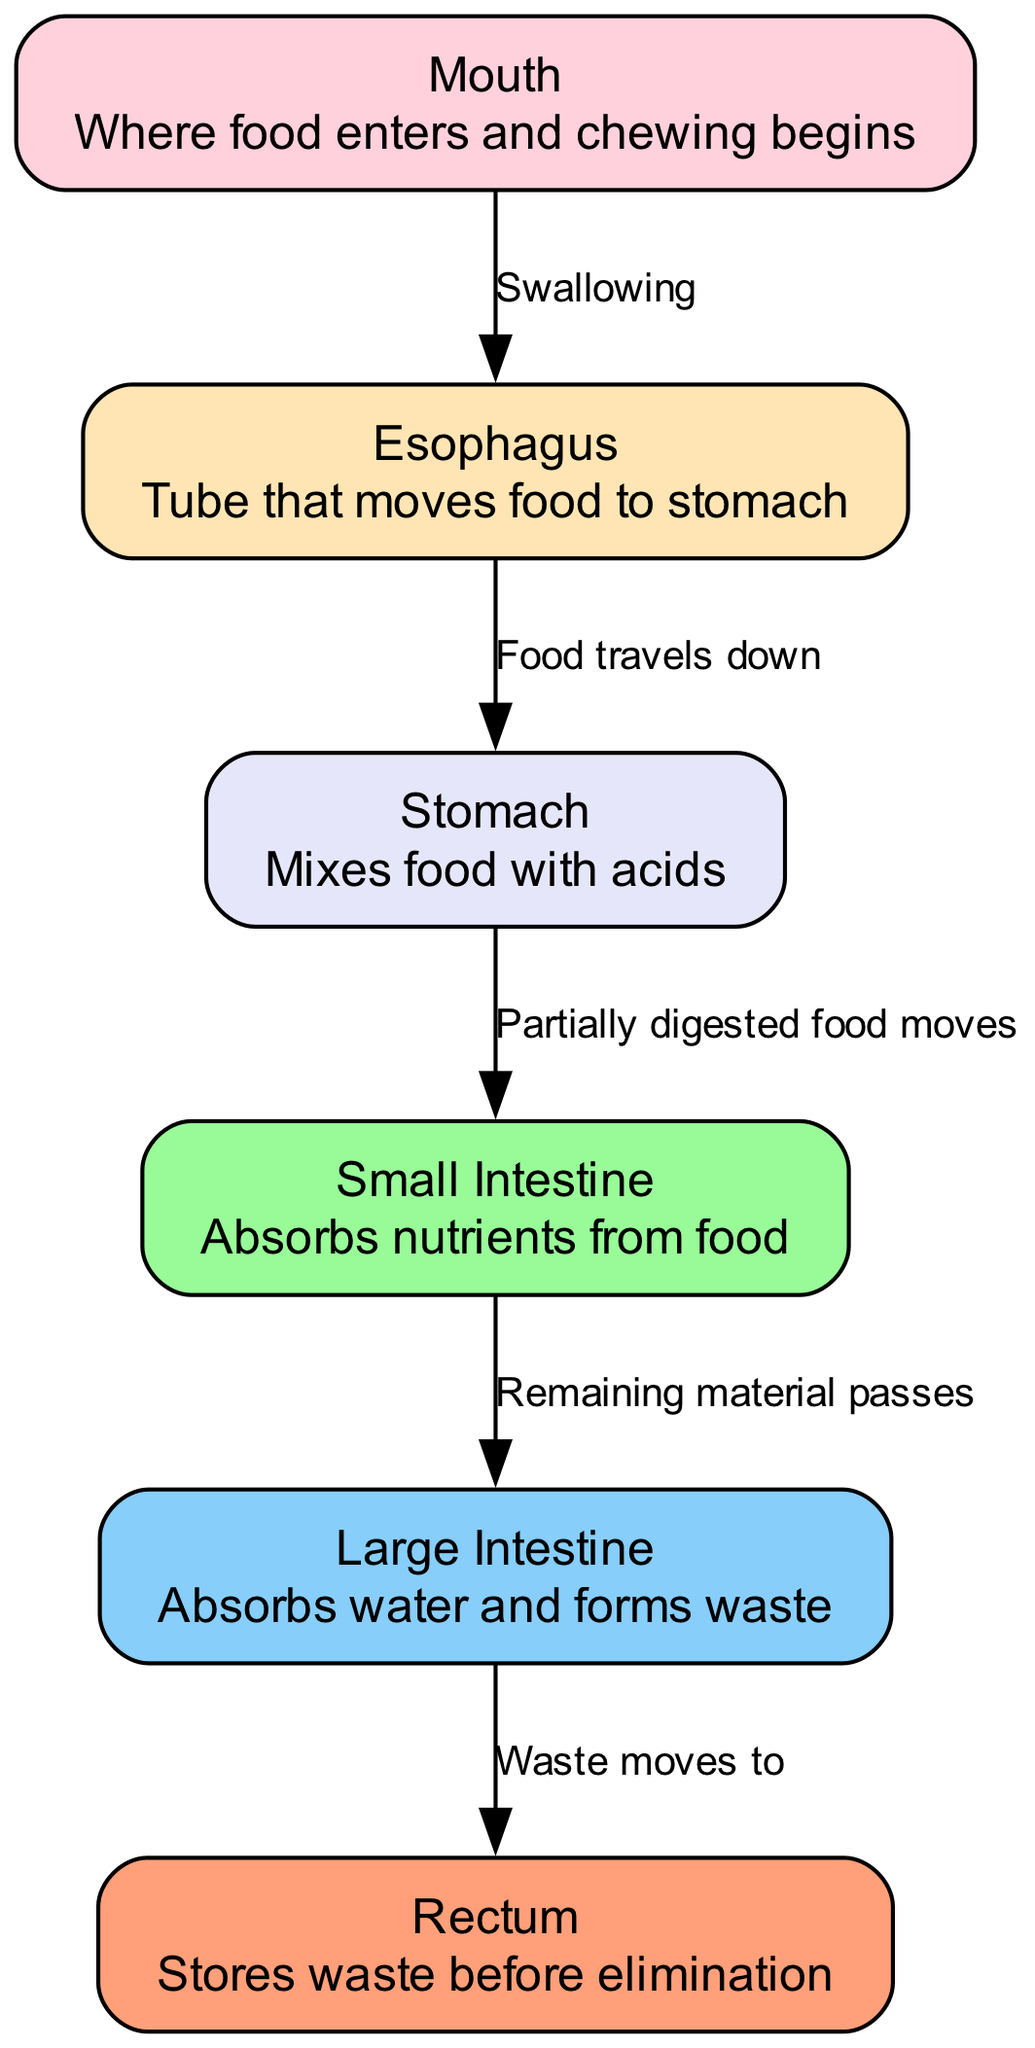What is the first organ food enters in the digestive system? The diagram indicates the flow of food starting from the mouth, where food enters and chewing begins.
Answer: Mouth How many nodes are present in the diagram? By counting each labeled organ and segment in the diagram, we identify six nodes: mouth, esophagus, stomach, small intestine, large intestine, and rectum.
Answer: Six What is the label for the second organ in the path of food? The second organ after the mouth is the esophagus, as indicated in the flow of the food journey.
Answer: Esophagus What does the stomach do to food? The stomach mixes food with acids, which is explicitly stated in the description of the stomach node in the diagram.
Answer: Mixes food with acids What direction does food travel after the esophagus? The diagram specifies that food travels down to the stomach after being pushed through the esophagus, which is detailed in the edge label connecting these two nodes.
Answer: Down What happens to food after it leaves the stomach? After the stomach, partially digested food moves to the small intestine, as shown in the diagram's progression between these two organs.
Answer: Moves to small intestine What is the purpose of the large intestine in the digestive process? The large intestine absorbs water and forms waste, which is clearly described in the node for the large intestine within the diagram.
Answer: Absorbs water and forms waste What connects the large intestine to the rectum? The movement of waste from the large intestine to the rectum is indicated as an edge in the diagram, highlighting this connection.
Answer: Waste moves to Which part of the digestive system is responsible for nutrient absorption? The small intestine is responsible for absorbing nutrients from food, as described in its node in the diagram.
Answer: Small intestine 